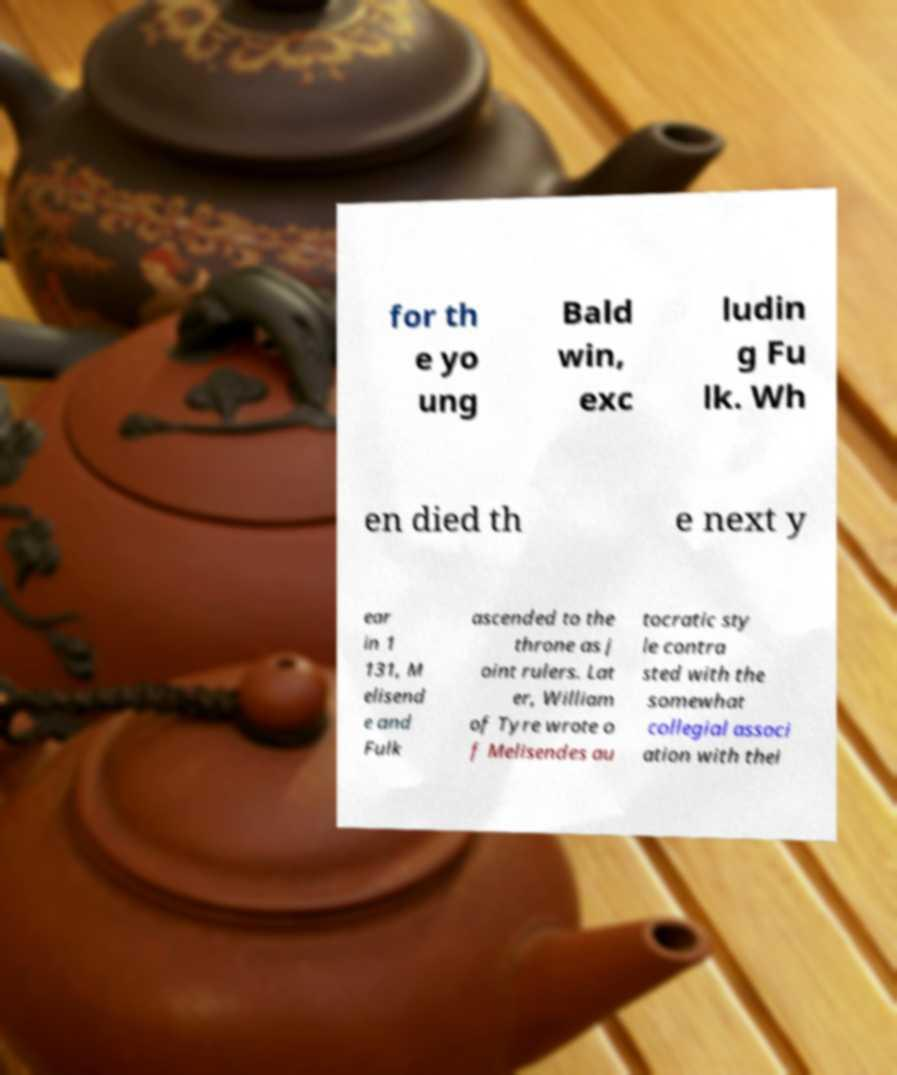I need the written content from this picture converted into text. Can you do that? for th e yo ung Bald win, exc ludin g Fu lk. Wh en died th e next y ear in 1 131, M elisend e and Fulk ascended to the throne as j oint rulers. Lat er, William of Tyre wrote o f Melisendes au tocratic sty le contra sted with the somewhat collegial associ ation with thei 